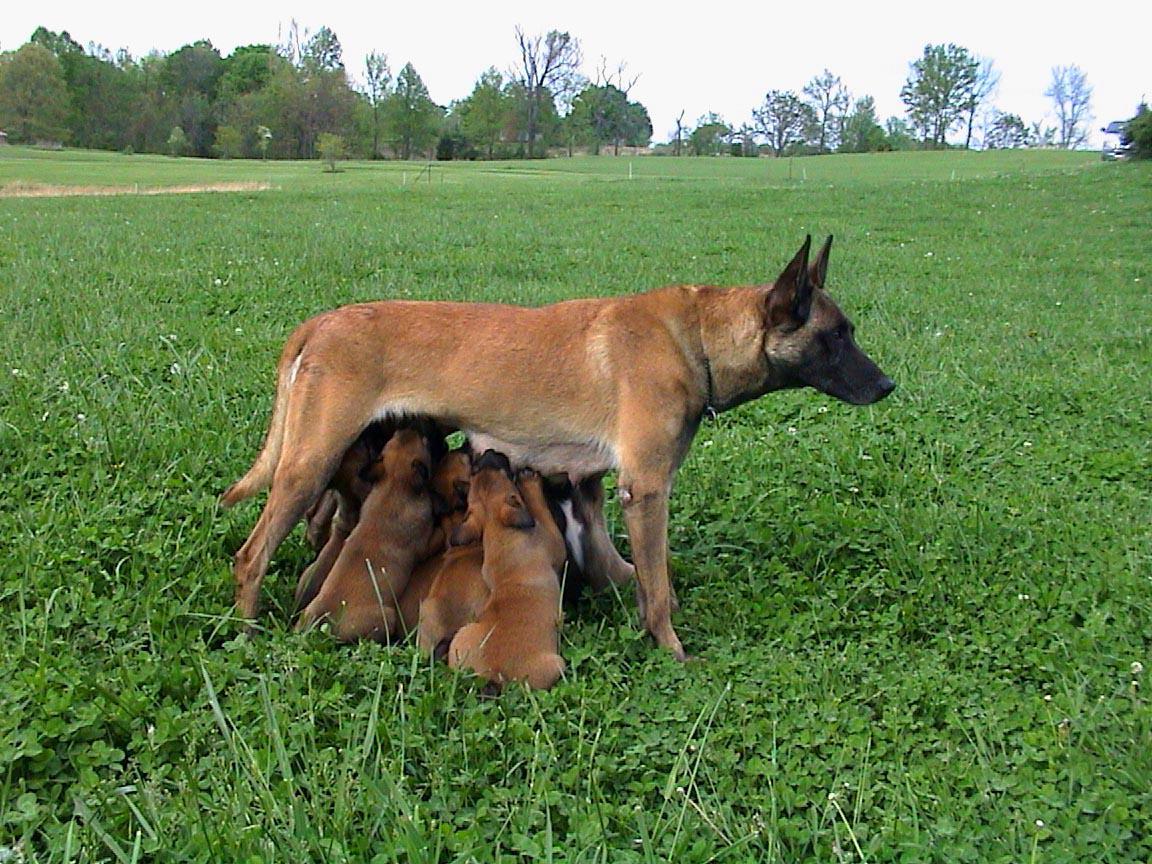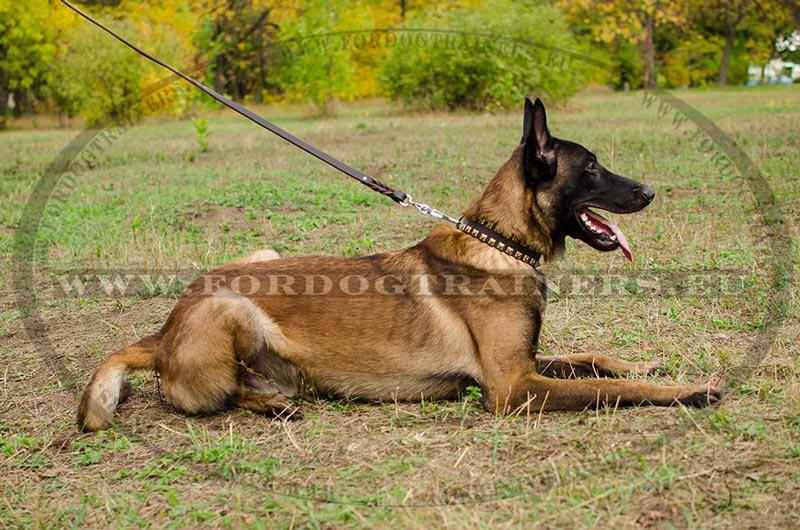The first image is the image on the left, the second image is the image on the right. Assess this claim about the two images: "One image shows two adult german shepherd dogs posed similarly side-by-side.". Correct or not? Answer yes or no. No. The first image is the image on the left, the second image is the image on the right. Analyze the images presented: Is the assertion "At least one dog is standing near a fence in the image on the left." valid? Answer yes or no. No. 